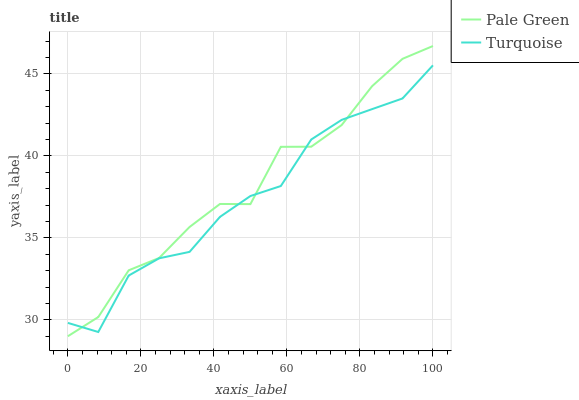Does Turquoise have the minimum area under the curve?
Answer yes or no. Yes. Does Pale Green have the maximum area under the curve?
Answer yes or no. Yes. Does Pale Green have the minimum area under the curve?
Answer yes or no. No. Is Turquoise the smoothest?
Answer yes or no. Yes. Is Pale Green the roughest?
Answer yes or no. Yes. Is Pale Green the smoothest?
Answer yes or no. No. Does Pale Green have the lowest value?
Answer yes or no. Yes. Does Pale Green have the highest value?
Answer yes or no. Yes. Does Pale Green intersect Turquoise?
Answer yes or no. Yes. Is Pale Green less than Turquoise?
Answer yes or no. No. Is Pale Green greater than Turquoise?
Answer yes or no. No. 